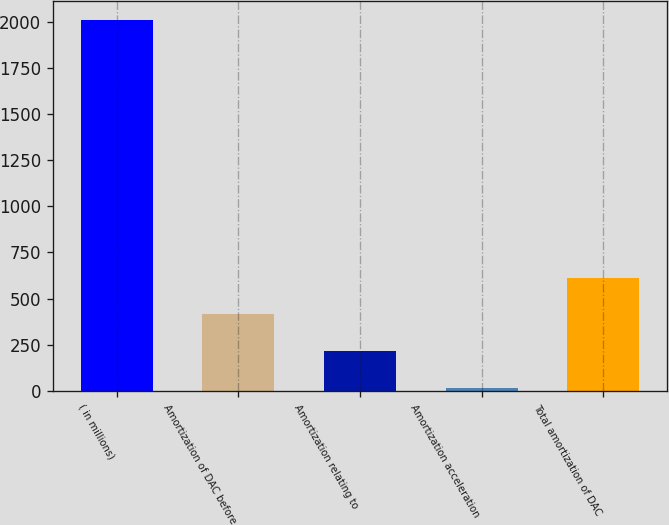Convert chart to OTSL. <chart><loc_0><loc_0><loc_500><loc_500><bar_chart><fcel>( in millions)<fcel>Amortization of DAC before<fcel>Amortization relating to<fcel>Amortization acceleration<fcel>Total amortization of DAC<nl><fcel>2010<fcel>414.8<fcel>215.4<fcel>16<fcel>614.2<nl></chart> 